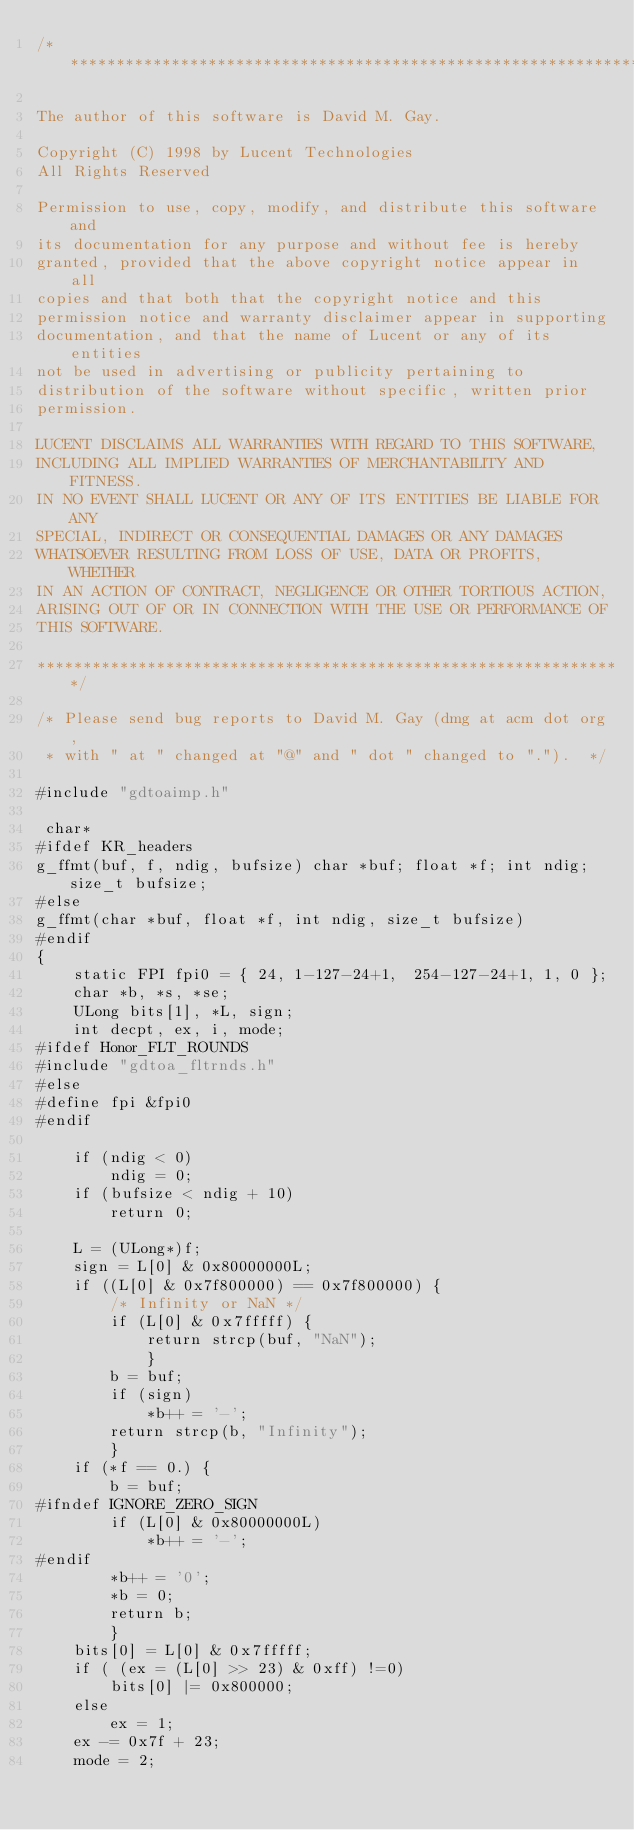Convert code to text. <code><loc_0><loc_0><loc_500><loc_500><_C_>/****************************************************************

The author of this software is David M. Gay.

Copyright (C) 1998 by Lucent Technologies
All Rights Reserved

Permission to use, copy, modify, and distribute this software and
its documentation for any purpose and without fee is hereby
granted, provided that the above copyright notice appear in all
copies and that both that the copyright notice and this
permission notice and warranty disclaimer appear in supporting
documentation, and that the name of Lucent or any of its entities
not be used in advertising or publicity pertaining to
distribution of the software without specific, written prior
permission.

LUCENT DISCLAIMS ALL WARRANTIES WITH REGARD TO THIS SOFTWARE,
INCLUDING ALL IMPLIED WARRANTIES OF MERCHANTABILITY AND FITNESS.
IN NO EVENT SHALL LUCENT OR ANY OF ITS ENTITIES BE LIABLE FOR ANY
SPECIAL, INDIRECT OR CONSEQUENTIAL DAMAGES OR ANY DAMAGES
WHATSOEVER RESULTING FROM LOSS OF USE, DATA OR PROFITS, WHETHER
IN AN ACTION OF CONTRACT, NEGLIGENCE OR OTHER TORTIOUS ACTION,
ARISING OUT OF OR IN CONNECTION WITH THE USE OR PERFORMANCE OF
THIS SOFTWARE.

****************************************************************/

/* Please send bug reports to David M. Gay (dmg at acm dot org,
 * with " at " changed at "@" and " dot " changed to ".").	*/

#include "gdtoaimp.h"

 char*
#ifdef KR_headers
g_ffmt(buf, f, ndig, bufsize) char *buf; float *f; int ndig; size_t bufsize;
#else
g_ffmt(char *buf, float *f, int ndig, size_t bufsize)
#endif
{
	static FPI fpi0 = { 24, 1-127-24+1,  254-127-24+1, 1, 0 };
	char *b, *s, *se;
	ULong bits[1], *L, sign;
	int decpt, ex, i, mode;
#ifdef Honor_FLT_ROUNDS
#include "gdtoa_fltrnds.h"
#else
#define fpi &fpi0
#endif

	if (ndig < 0)
		ndig = 0;
	if (bufsize < ndig + 10)
		return 0;

	L = (ULong*)f;
	sign = L[0] & 0x80000000L;
	if ((L[0] & 0x7f800000) == 0x7f800000) {
		/* Infinity or NaN */
		if (L[0] & 0x7fffff) {
			return strcp(buf, "NaN");
			}
		b = buf;
		if (sign)
			*b++ = '-';
		return strcp(b, "Infinity");
		}
	if (*f == 0.) {
		b = buf;
#ifndef IGNORE_ZERO_SIGN
		if (L[0] & 0x80000000L)
			*b++ = '-';
#endif
		*b++ = '0';
		*b = 0;
		return b;
		}
	bits[0] = L[0] & 0x7fffff;
	if ( (ex = (L[0] >> 23) & 0xff) !=0)
		bits[0] |= 0x800000;
	else
		ex = 1;
	ex -= 0x7f + 23;
	mode = 2;</code> 